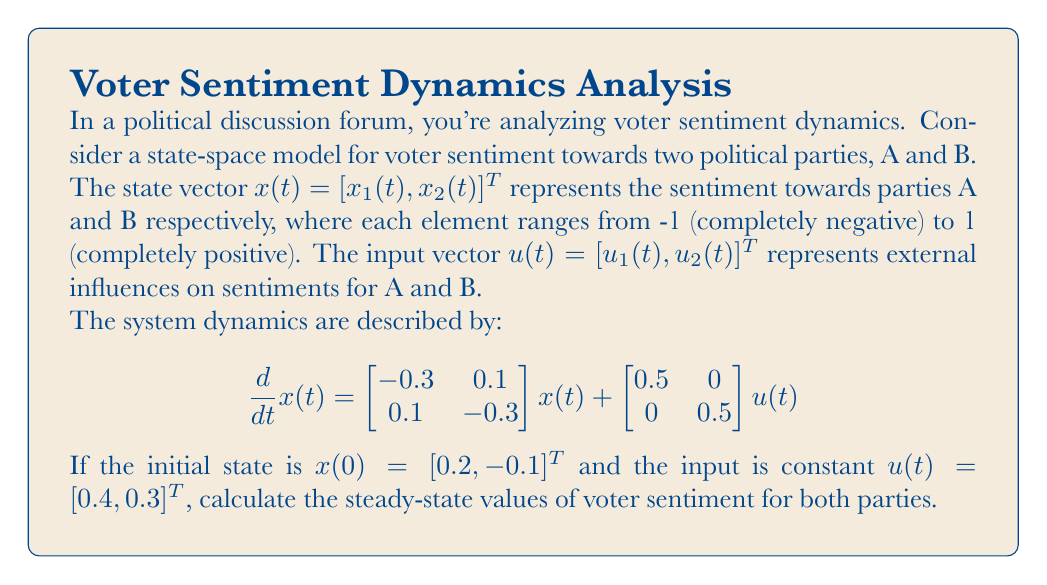What is the answer to this math problem? To find the steady-state values, we need to follow these steps:

1) In steady-state, the rate of change of the state vector is zero. So, we set $\frac{d}{dt}x(t) = 0$:

   $$0 = \begin{bmatrix} -0.3 & 0.1 \\ 0.1 & -0.3 \end{bmatrix}x_{ss} + \begin{bmatrix} 0.5 & 0 \\ 0 & 0.5 \end{bmatrix}u$$

2) Substitute the given constant input $u = [0.4, 0.3]^T$:

   $$0 = \begin{bmatrix} -0.3 & 0.1 \\ 0.1 & -0.3 \end{bmatrix}x_{ss} + \begin{bmatrix} 0.5 & 0 \\ 0 & 0.5 \end{bmatrix}\begin{bmatrix} 0.4 \\ 0.3 \end{bmatrix}$$

3) Simplify the right-hand side:

   $$0 = \begin{bmatrix} -0.3 & 0.1 \\ 0.1 & -0.3 \end{bmatrix}x_{ss} + \begin{bmatrix} 0.2 \\ 0.15 \end{bmatrix}$$

4) Let $x_{ss} = [x_1, x_2]^T$. Now we have a system of linear equations:

   $$\begin{aligned}
   0 &= -0.3x_1 + 0.1x_2 + 0.2 \\
   0 &= 0.1x_1 - 0.3x_2 + 0.15
   \end{aligned}$$

5) Solve this system of equations:
   - Multiply the first equation by 3 and the second by -1:
     $$\begin{aligned}
     0 &= -0.9x_1 + 0.3x_2 + 0.6 \\
     0 &= -0.1x_1 + 0.3x_2 - 0.15
     \end{aligned}$$
   - Add these equations:
     $$0 = -x_1 + 0.6x_2 + 0.45$$
   - Substitute this into one of the original equations:
     $$\begin{aligned}
     0 &= -0.3(0.6x_2 + 0.45) + 0.1x_2 + 0.2 \\
     0 &= -0.18x_2 - 0.135 + 0.1x_2 + 0.2 \\
     0 &= -0.08x_2 + 0.065 \\
     x_2 &= 0.8125
     \end{aligned}$$
   - Substitute back to find $x_1$:
     $$\begin{aligned}
     x_1 &= 0.6x_2 + 0.45 \\
     x_1 &= 0.6(0.8125) + 0.45 \\
     x_1 &= 0.9375
     \end{aligned}$$

Therefore, the steady-state vector is $x_{ss} = [0.9375, 0.8125]^T$.
Answer: $x_{ss} = [0.9375, 0.8125]^T$ 